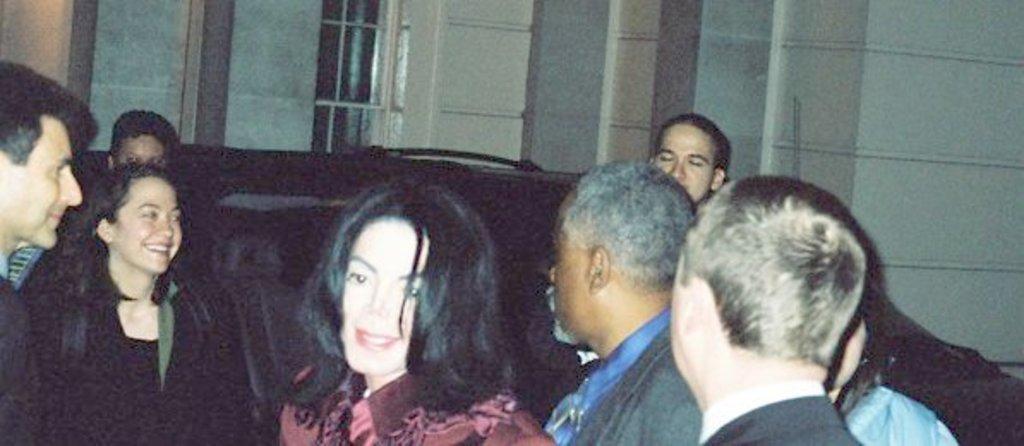How would you summarize this image in a sentence or two? In the image there are few women and women standing in the front with a car behind them and over the background there is a building. 